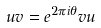Convert formula to latex. <formula><loc_0><loc_0><loc_500><loc_500>u v = e ^ { 2 \pi i \theta } v u</formula> 